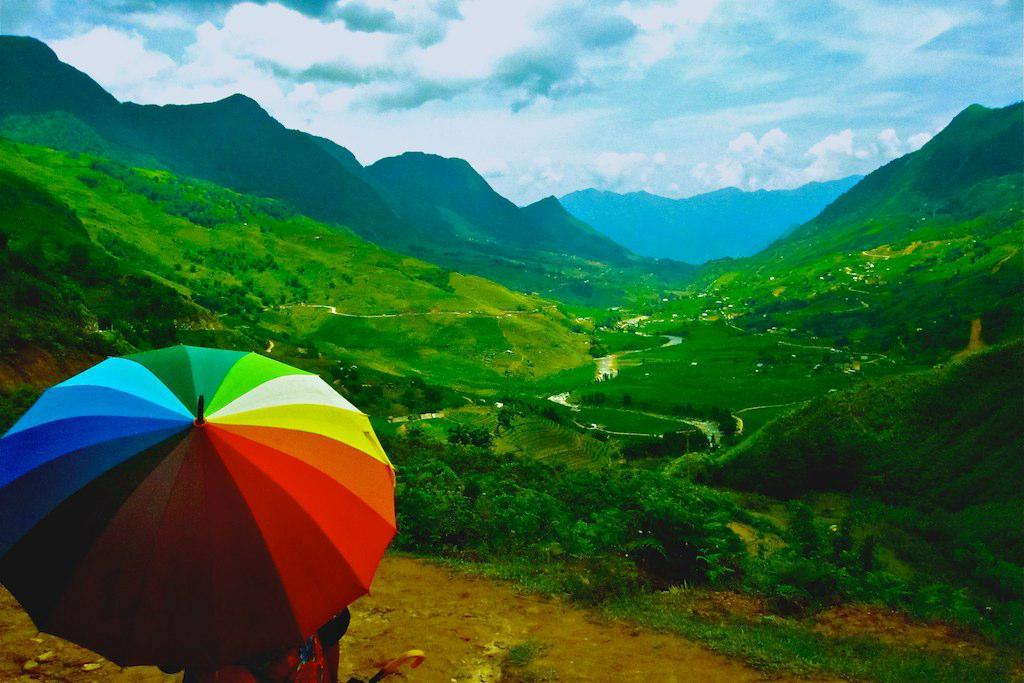What is the main subject of the image? There is a person in the image. What is the person holding in the image? The person is holding an umbrella. What can be seen in the background of the image? There are trees, hills, and the sky visible in the background of the image. What is the condition of the sky in the image? Clouds are present in the sky. What type of glove is the person wearing in the image? There is no glove visible in the image; the person is holding an umbrella. What angle is the person standing at in the image? The angle at which the person is standing cannot be determined from the image. 